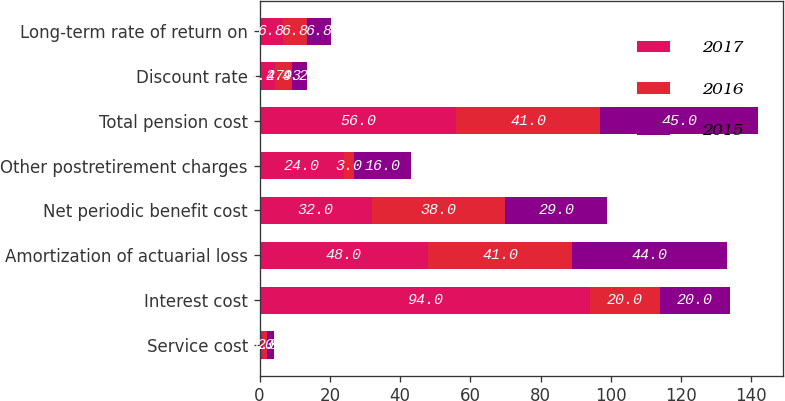Convert chart to OTSL. <chart><loc_0><loc_0><loc_500><loc_500><stacked_bar_chart><ecel><fcel>Service cost<fcel>Interest cost<fcel>Amortization of actuarial loss<fcel>Net periodic benefit cost<fcel>Other postretirement charges<fcel>Total pension cost<fcel>Discount rate<fcel>Long-term rate of return on<nl><fcel>2017<fcel>1<fcel>94<fcel>48<fcel>32<fcel>24<fcel>56<fcel>4.27<fcel>6.8<nl><fcel>2016<fcel>1<fcel>20<fcel>41<fcel>38<fcel>3<fcel>41<fcel>4.93<fcel>6.8<nl><fcel>2015<fcel>2<fcel>20<fcel>44<fcel>29<fcel>16<fcel>45<fcel>4.24<fcel>6.8<nl></chart> 